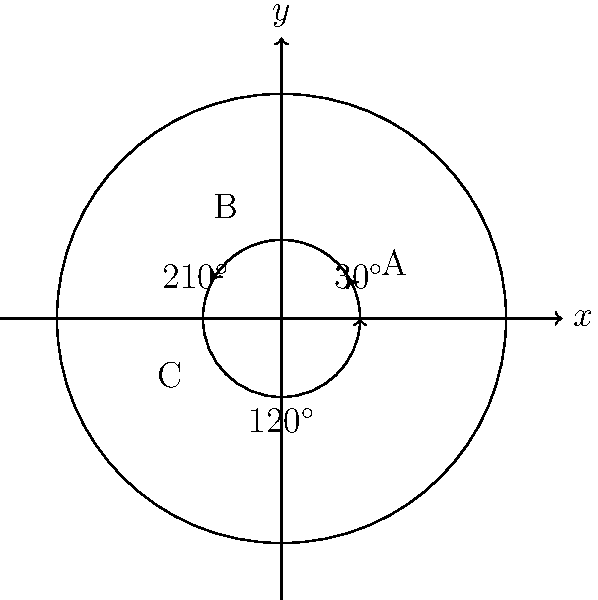In a recent study of metastatic cancer cell distribution, oncologists observed an angular pattern of cell spread from the primary tumor site. The diagram represents this distribution, where the circle's center is the primary tumor location. If 50% of metastatic cells are found in region A, 30% in region B, and 20% in region C, what is the average angle (in degrees) between two randomly selected metastatic cancer cells? To solve this problem, we need to follow these steps:

1. Understand the angular regions:
   Region A: $0^\circ$ to $30^\circ$
   Region B: $30^\circ$ to $150^\circ$
   Region C: $150^\circ$ to $360^\circ$

2. Calculate the average angle for each region:
   Region A: $(0^\circ + 30^\circ) / 2 = 15^\circ$
   Region B: $(30^\circ + 150^\circ) / 2 = 90^\circ$
   Region C: $(150^\circ + 360^\circ) / 2 = 255^\circ$

3. Calculate the weighted average of these angles based on the percentage of cells in each region:
   $\text{Weighted Average} = (0.50 \times 15^\circ) + (0.30 \times 90^\circ) + (0.20 \times 255^\circ)$

4. Compute the result:
   $\text{Weighted Average} = 7.5^\circ + 27^\circ + 51^\circ = 85.5^\circ$

5. The average angle between two randomly selected cells is twice this weighted average:
   $\text{Average Angle} = 2 \times 85.5^\circ = 171^\circ$

This is because if we randomly select two cells, on average, one will be $85.5^\circ$ clockwise from the mean direction, and the other will be $85.5^\circ$ counterclockwise, resulting in a total average angle of $171^\circ$ between them.
Answer: $171^\circ$ 